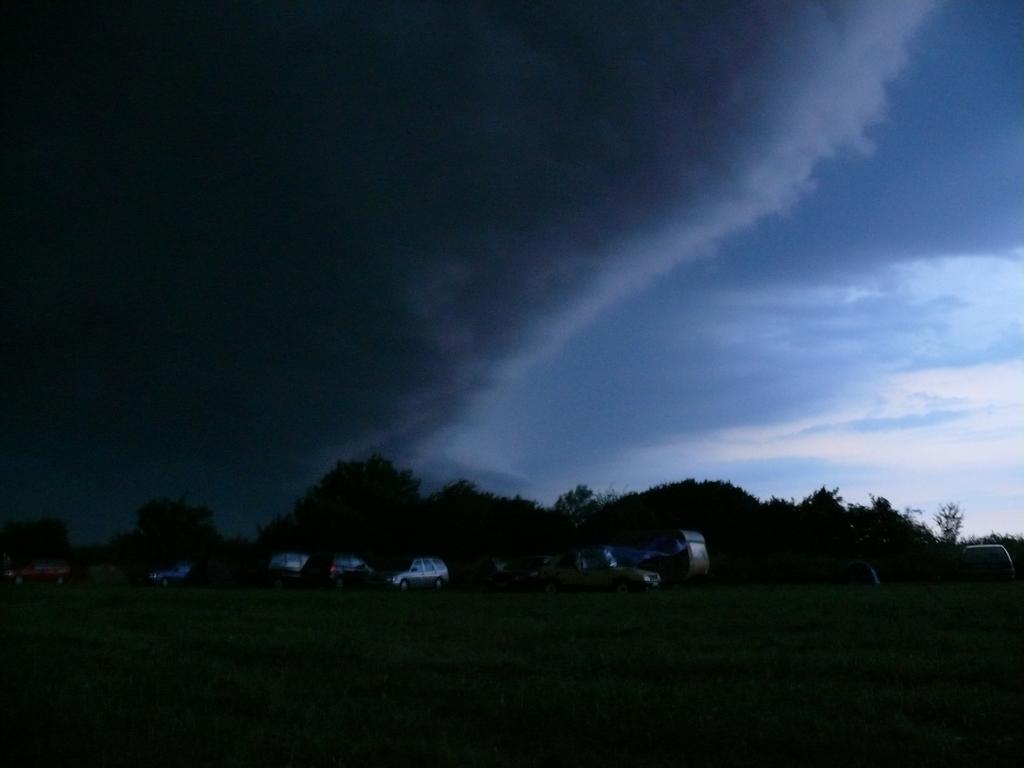Can you describe this image briefly? In this picture we can see a few vehicles and trees in the background. Sky is cloudy. 